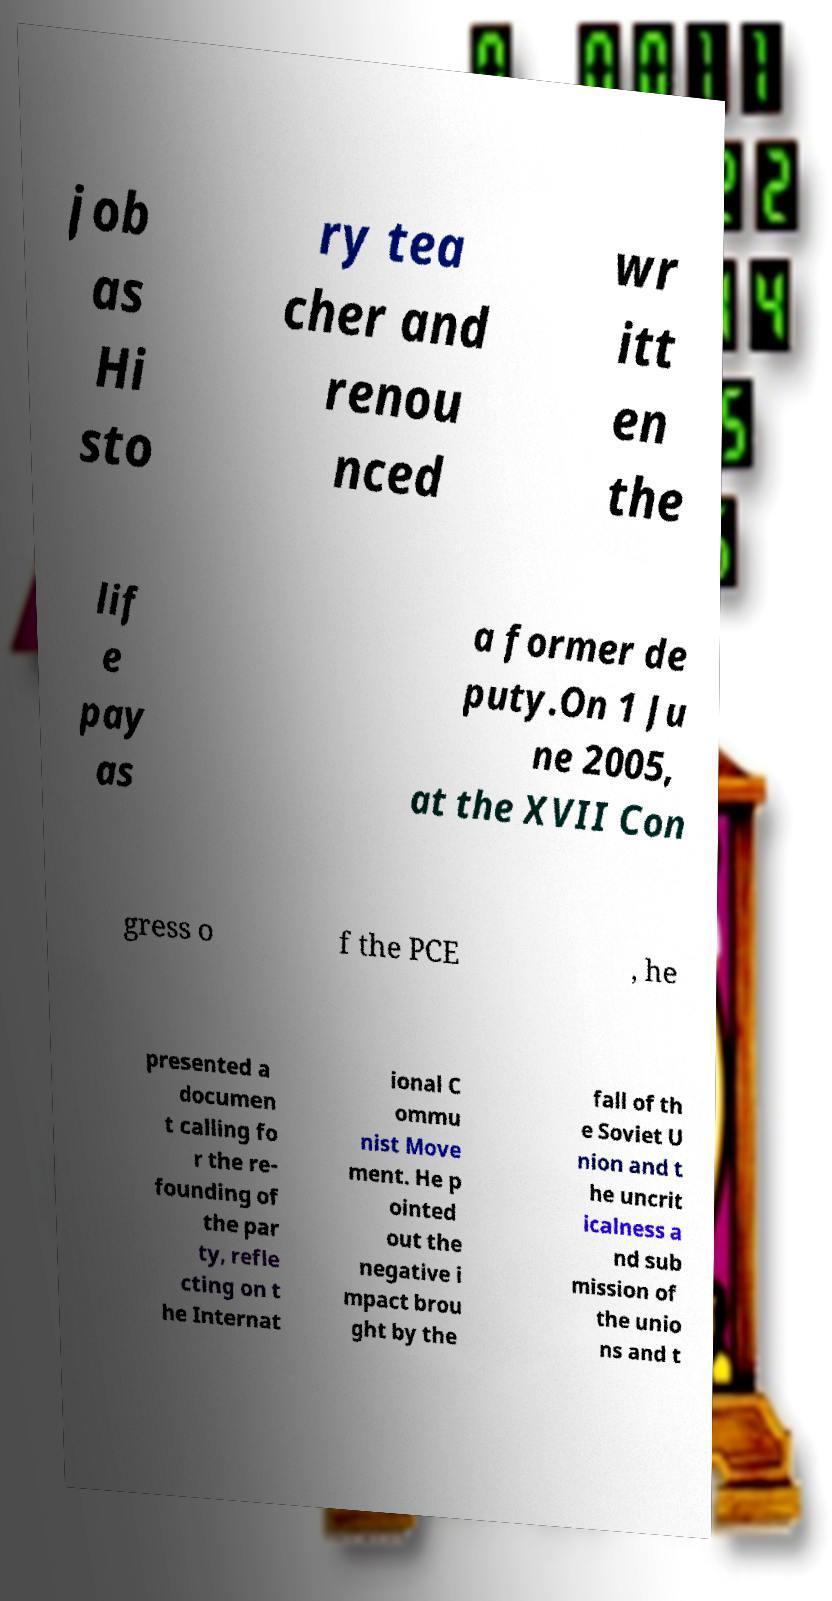I need the written content from this picture converted into text. Can you do that? job as Hi sto ry tea cher and renou nced wr itt en the lif e pay as a former de puty.On 1 Ju ne 2005, at the XVII Con gress o f the PCE , he presented a documen t calling fo r the re- founding of the par ty, refle cting on t he Internat ional C ommu nist Move ment. He p ointed out the negative i mpact brou ght by the fall of th e Soviet U nion and t he uncrit icalness a nd sub mission of the unio ns and t 